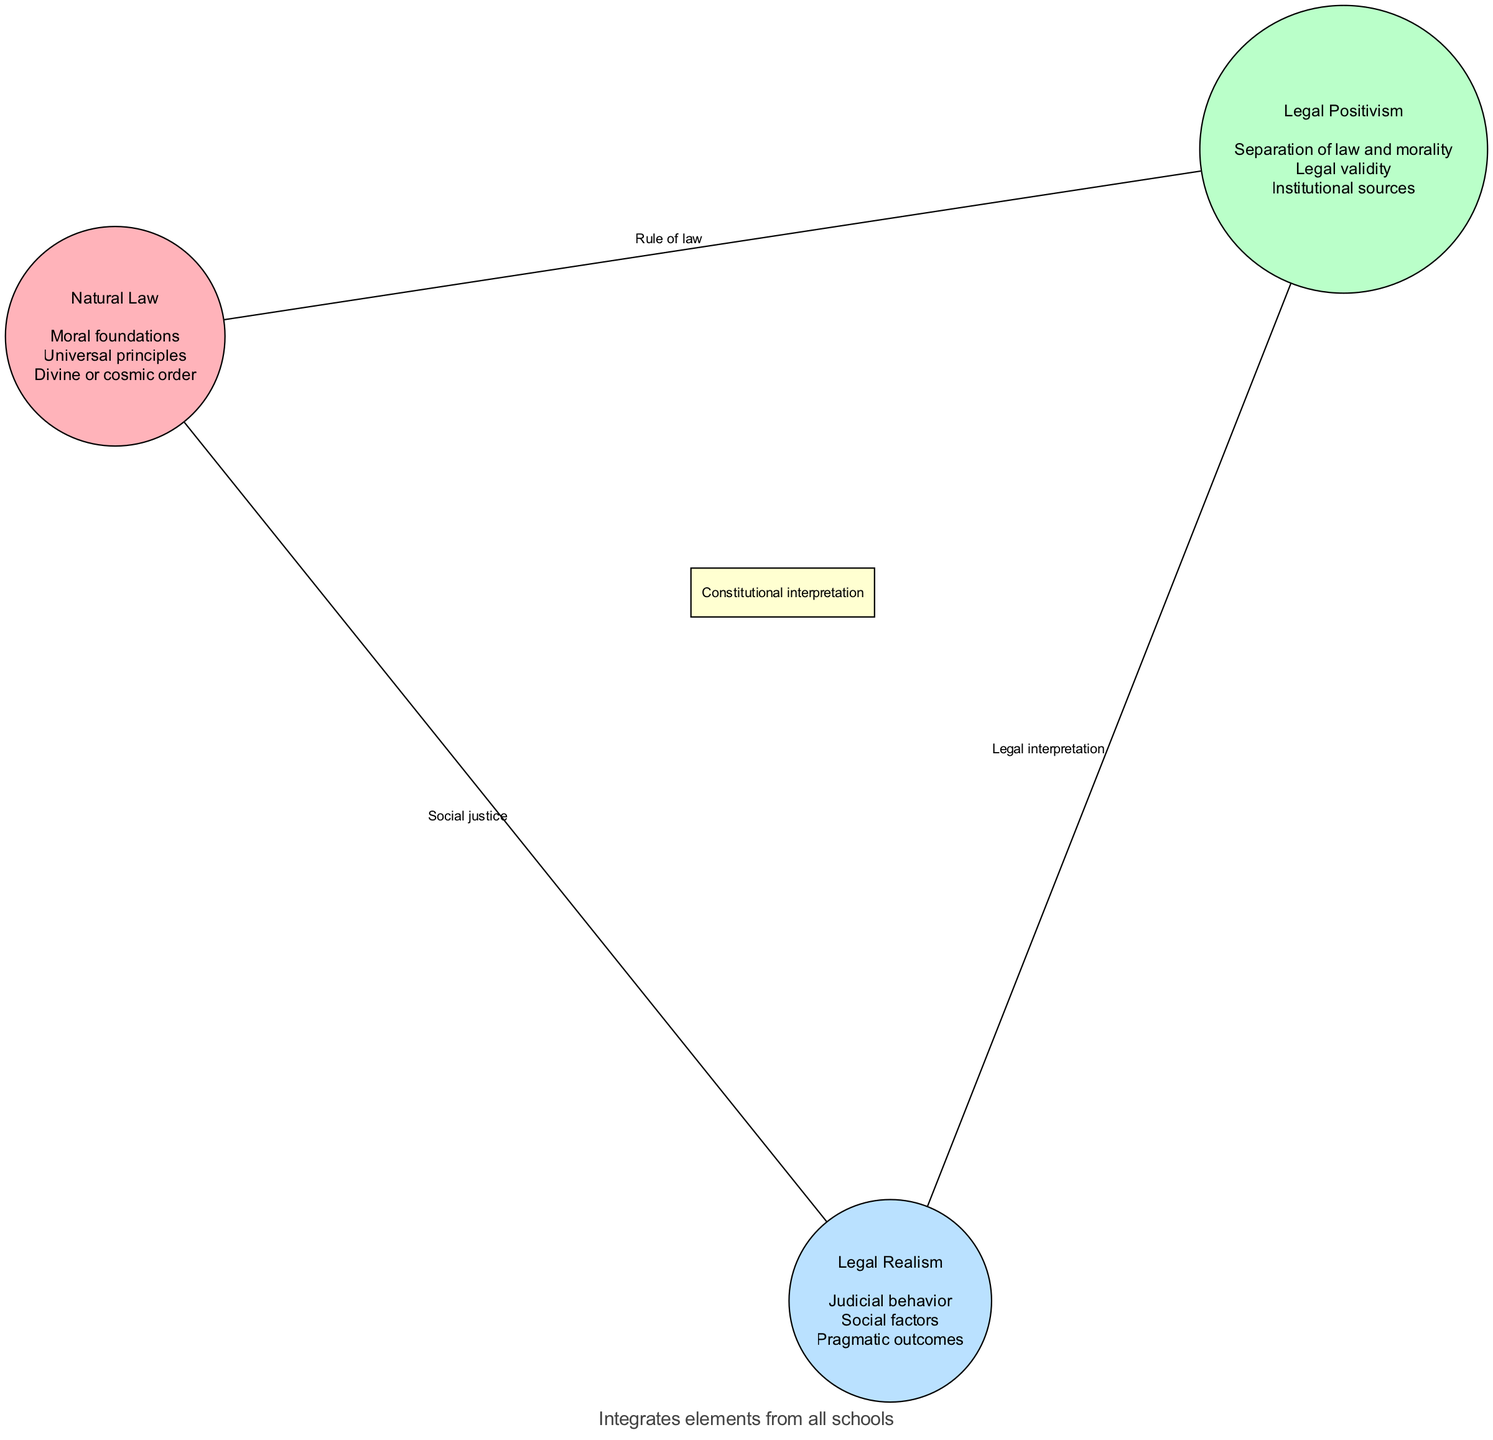What are the moral foundations associated with Natural Law? The diagram lists "Moral foundations" as one of the elements of the Natural Law circle. Since it is explicitly mentioned, we can directly identify it from the visual representation.
Answer: Moral foundations What common element is shared between Natural Law and Legal Positivism? The intersection between Natural Law and Legal Positivism is labeled "Rule of law". We identify this by looking at the overlapping area between the two sets in the diagram.
Answer: Rule of law What is a key aspect of Legal Realism? The element "Judicial behavior" is specifically associated with Legal Realism as indicated in its circle within the diagram. This is a direct reference to what characterizes this school of thought.
Answer: Judicial behavior How many elements are found in the Legal Positivism circle? The Legal Positivism circle lists three elements: "Separation of law and morality", "Legal validity", and "Institutional sources". Counting these elements gives us a total of three.
Answer: Three What element is shared among all three legal philosophies? The diagram shows that "Constitutional interpretation" is present in the overlapping center where all three sets intersect. This indicates that it is a common element among them all.
Answer: Constitutional interpretation What element connects Legal Positivism and Legal Realism? In the diagram, the intersection of Legal Positivism and Legal Realism is annotated with "Legal interpretation". This is a direct connection shown at the overlapping region of the two circles.
Answer: Legal interpretation According to the diagram, which theory integrates elements from all schools? The annotation at the top of the diagram states "Unconventional theory: Dynamic Constitutionalism", indicating this theory draws from all the different legal philosophies represented in the Venn diagram.
Answer: Dynamic Constitutionalism How many total intersections are shown in the diagram? The diagram displays four distinct intersections: Natural Law with Legal Positivism, Legal Positivism with Legal Realism, Natural Law with Legal Realism, and all three together. Therefore, the total count is four.
Answer: Four What text is present at the bottom of the diagram? The bottom annotation states "Integrates elements from all schools", which summarizes the concept conveyed at that position, according to the provided details of the diagram.
Answer: Integrates elements from all schools 